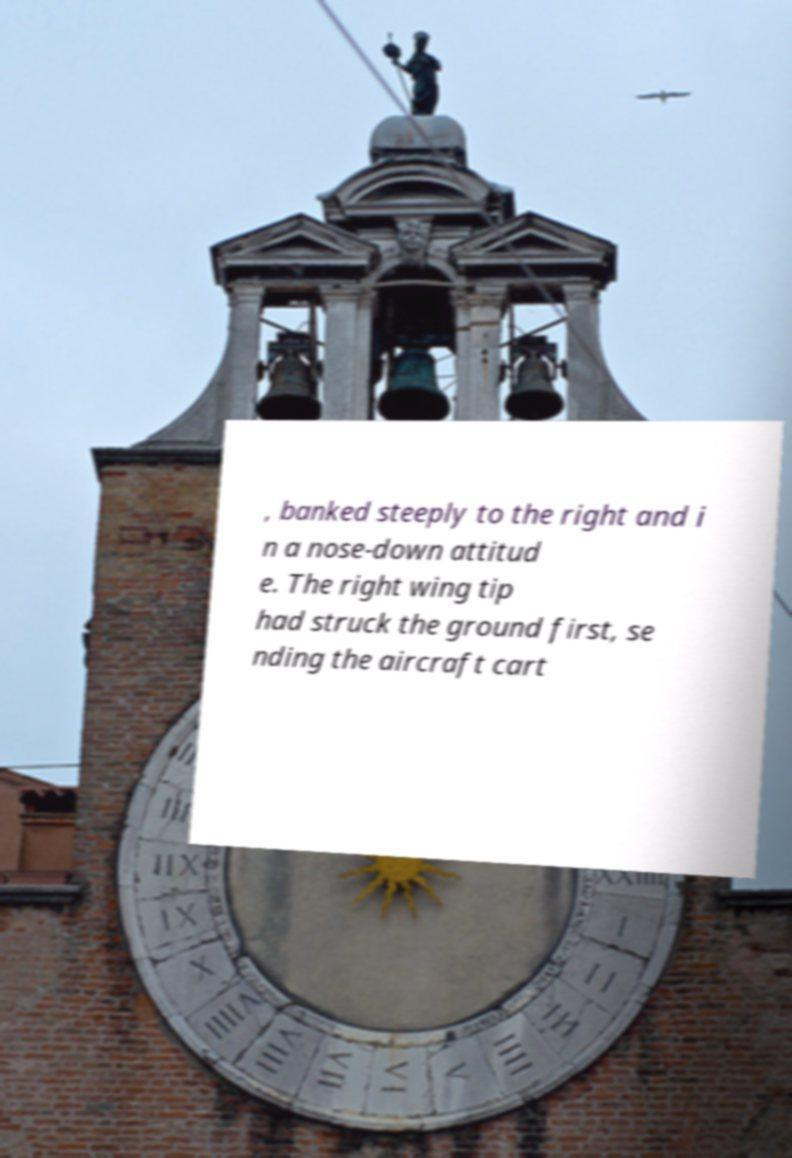For documentation purposes, I need the text within this image transcribed. Could you provide that? , banked steeply to the right and i n a nose-down attitud e. The right wing tip had struck the ground first, se nding the aircraft cart 